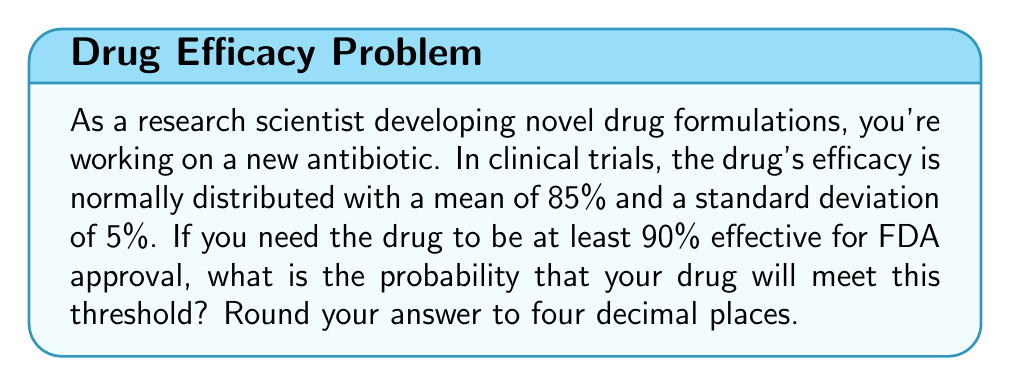What is the answer to this math problem? To solve this problem, we need to use the properties of the normal distribution and calculate a z-score.

1. Identify the given information:
   - Mean efficacy (μ) = 85%
   - Standard deviation (σ) = 5%
   - Threshold for approval = 90%

2. Calculate the z-score for the threshold value:
   $$z = \frac{x - μ}{σ}$$
   Where x is the threshold value (90%)
   
   $$z = \frac{90 - 85}{5} = 1$$

3. Use the standard normal distribution table or a calculator to find the probability of a z-score greater than 1.

   The probability of a z-score greater than 1 is equal to 1 minus the cumulative probability up to z = 1.

   $$P(Z > 1) = 1 - P(Z ≤ 1)$$

   From the standard normal distribution table:
   $$P(Z ≤ 1) ≈ 0.8413$$

   Therefore:
   $$P(Z > 1) = 1 - 0.8413 = 0.1587$$

4. Round the result to four decimal places:
   0.1587 rounds to 0.1587

This means there is approximately a 15.87% chance that the drug will meet or exceed the 90% efficacy threshold required for FDA approval.
Answer: 0.1587 